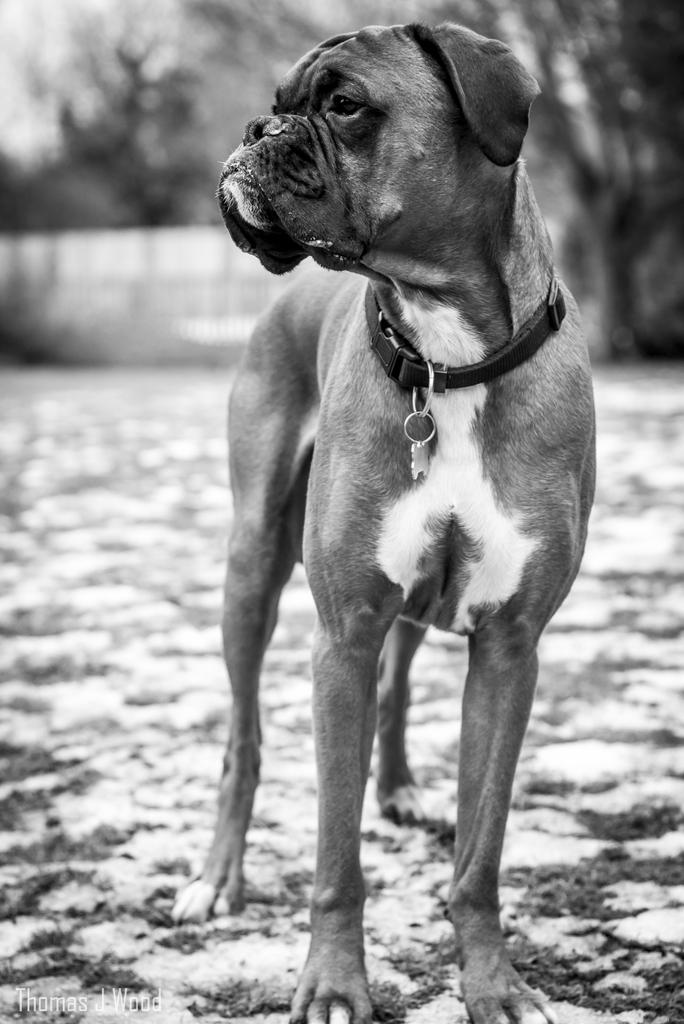What type of animal is in the image? There is a dog in the image. Where is the dog located? The dog is on the floor. Can you describe the background of the image? The background of the image is blurred. How many legs does the kitty have in the image? There is no kitty present in the image, so it is not possible to determine the number of legs it might have. 